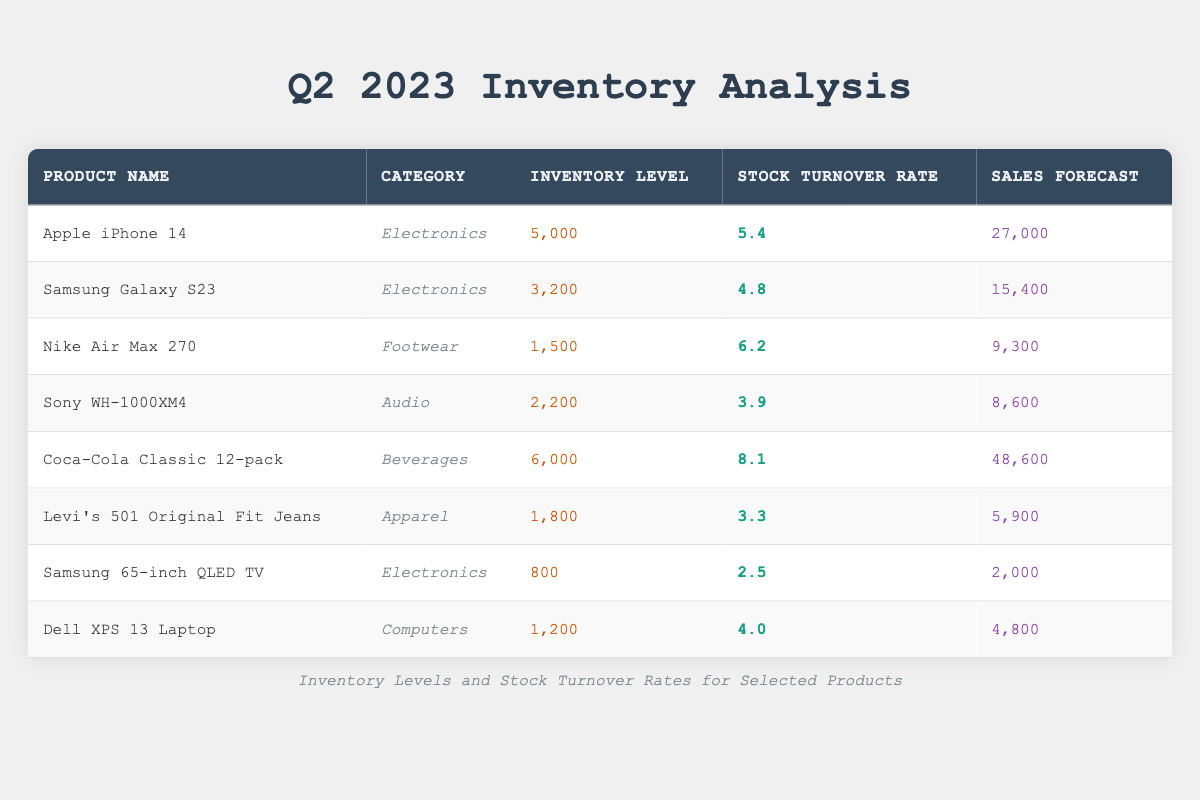What is the inventory level of the Coca-Cola Classic 12-pack? The inventory level for the Coca-Cola Classic 12-pack is explicitly provided in the table under the "Inventory Level" column. According to the data, it states the inventory level as 6,000.
Answer: 6,000 Which product has the highest stock turnover rate? To find the highest stock turnover rate, we compare the rates listed in the "Stock Turnover Rate" column. By reviewing the rates, we see that Coca-Cola Classic 12-pack has the highest rate at 8.1.
Answer: Coca-Cola Classic 12-pack What is the average inventory level of the footwear products? We identify the footwear products, which is the Nike Air Max 270, with an inventory level of 1,500. There is only one footwear product in the table, so the average is simply the inventory level itself. Thus, the average inventory level calculates to 1,500/1 = 1,500.
Answer: 1,500 Is the stock turnover rate of the Samsung Galaxy S23 greater than 4.5? The stock turnover rate for the Samsung Galaxy S23 is listed as 4.8. Since 4.8 is greater than 4.5, the answer to the question is true.
Answer: Yes What is the total sales forecast for all electronics products? First, we extract the sales forecasts for all electronics products: Apple iPhone 14 (27,000), Samsung Galaxy S23 (15,400), and Samsung 65-inch QLED TV (2,000). We sum these values: 27,000 + 15,400 + 2,000 = 44,400, making the total sales forecast for electronics products 44,400.
Answer: 44,400 Are there more Levi's 501 Original Fit Jeans or Nike Air Max 270 in inventory? The inventory levels for Levi's 501 Original Fit Jeans and Nike Air Max 270 are compared: 1,800 for Levi's and 1,500 for Nike. Since 1,800 is greater than 1,500, Levi's 501 has more inventory.
Answer: Yes What is the difference in stock turnover rate between the Apple iPhone 14 and Sony WH-1000XM4? The stock turnover rate for Apple iPhone 14 is 5.4, while for Sony WH-1000XM4, it is 3.9. To find the difference, we subtract: 5.4 - 3.9 = 1.5.
Answer: 1.5 Which category has the lowest stock turnover rate? We examine the stock turnover rates across all product categories. The rates are: Electronics (5.4, 4.8, 2.5), Footwear (6.2), Audio (3.9), Beverages (8.1), and Apparel (3.3). The Electronics category contains the lowest rate, which is 2.5 for Samsung 65-inch QLED TV.
Answer: Electronics What is the stock turnover rate of the Dell XPS 13 Laptop? The stock turnover rate of the Dell XPS 13 Laptop is directly available in the table, which states it as 4.0 in the "Stock Turnover Rate" column.
Answer: 4.0 